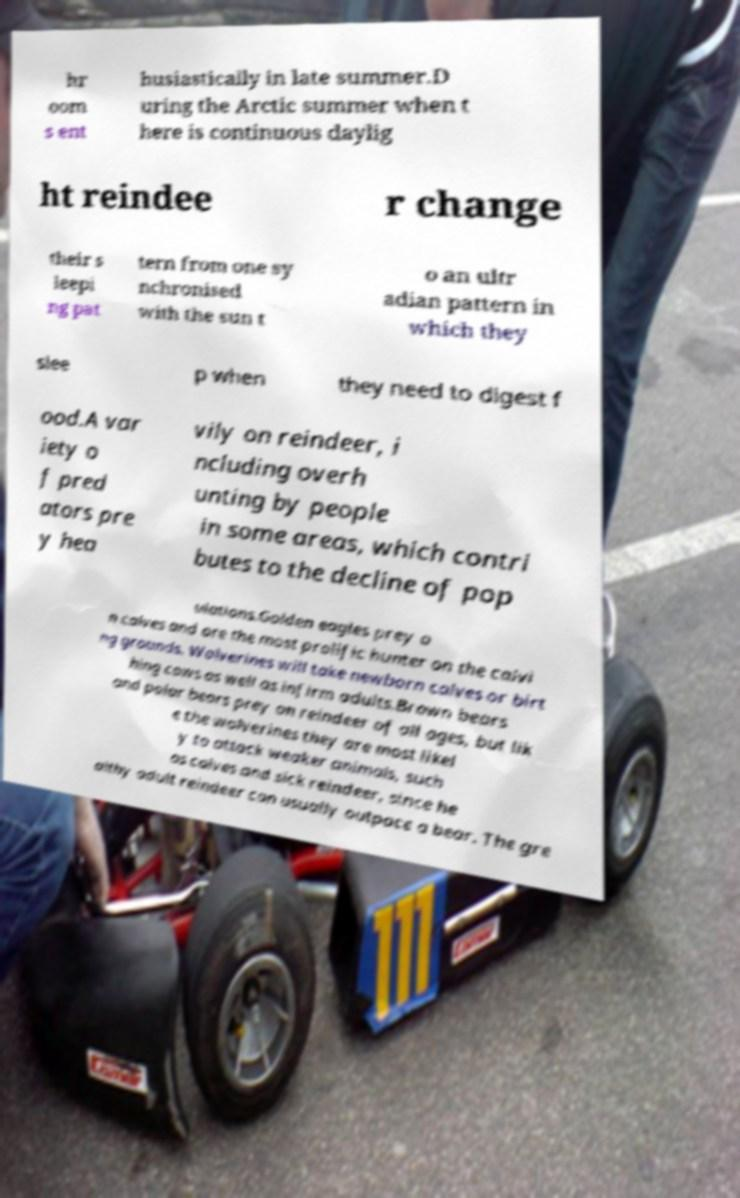Could you extract and type out the text from this image? hr oom s ent husiastically in late summer.D uring the Arctic summer when t here is continuous daylig ht reindee r change their s leepi ng pat tern from one sy nchronised with the sun t o an ultr adian pattern in which they slee p when they need to digest f ood.A var iety o f pred ators pre y hea vily on reindeer, i ncluding overh unting by people in some areas, which contri butes to the decline of pop ulations.Golden eagles prey o n calves and are the most prolific hunter on the calvi ng grounds. Wolverines will take newborn calves or birt hing cows as well as infirm adults.Brown bears and polar bears prey on reindeer of all ages, but lik e the wolverines they are most likel y to attack weaker animals, such as calves and sick reindeer, since he althy adult reindeer can usually outpace a bear. The gre 